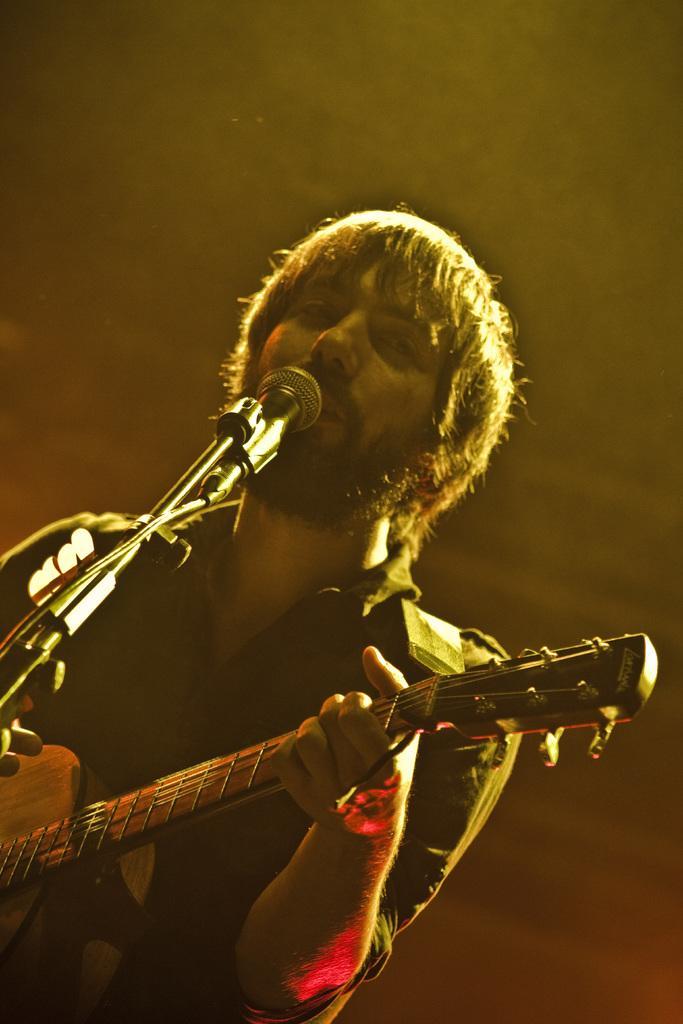Describe this image in one or two sentences. In this picture a man is singing and playing guitar in front of microphone. 